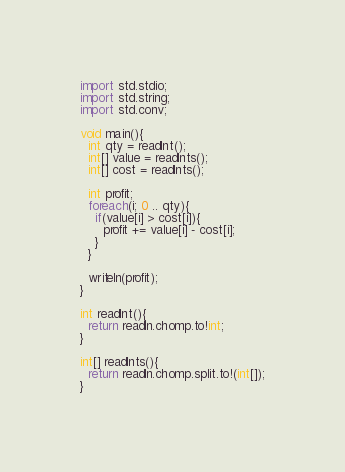Convert code to text. <code><loc_0><loc_0><loc_500><loc_500><_D_>import std.stdio;
import std.string;
import std.conv;

void main(){
  int qty = readInt();
  int[] value = readInts();
  int[] cost = readInts();
  
  int profit;
  foreach(i; 0 .. qty){
    if(value[i] > cost[i]){
      profit += value[i] - cost[i]; 
    }
  }
  
  writeln(profit);
}

int readInt(){
  return readln.chomp.to!int;
}

int[] readInts(){
  return readln.chomp.split.to!(int[]);
}</code> 